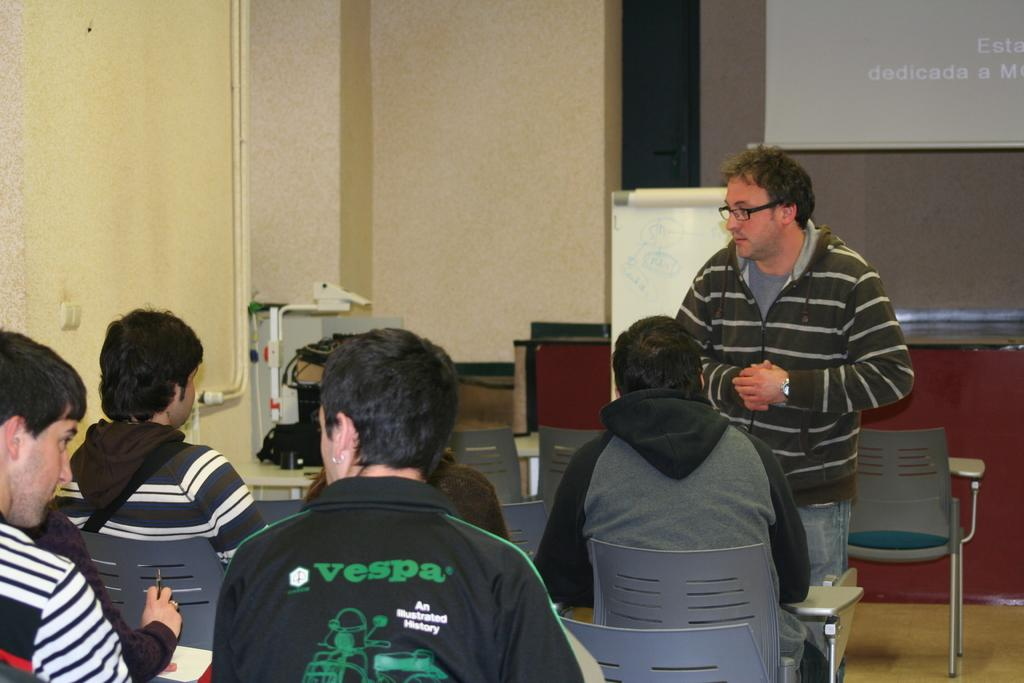What is the man in the image doing? The man is standing in the image. What is the man wearing in the image? The man is wearing a jacket and spectacles in the image. What can be seen in front of the man? There are people sitting in chairs in front of the man. What is visible in the background of the image? There is a screen, a wall, and pipes in the background of the image. What type of tail can be seen on the man in the image? There is no tail visible on the man in the image. What color is the sky in the image? There is no sky visible in the image; it is an indoor setting. How does the earthquake affect the man and the people in the image? There is no mention of an earthquake in the image or the provided facts, so we cannot determine its effects on the people in the image. 